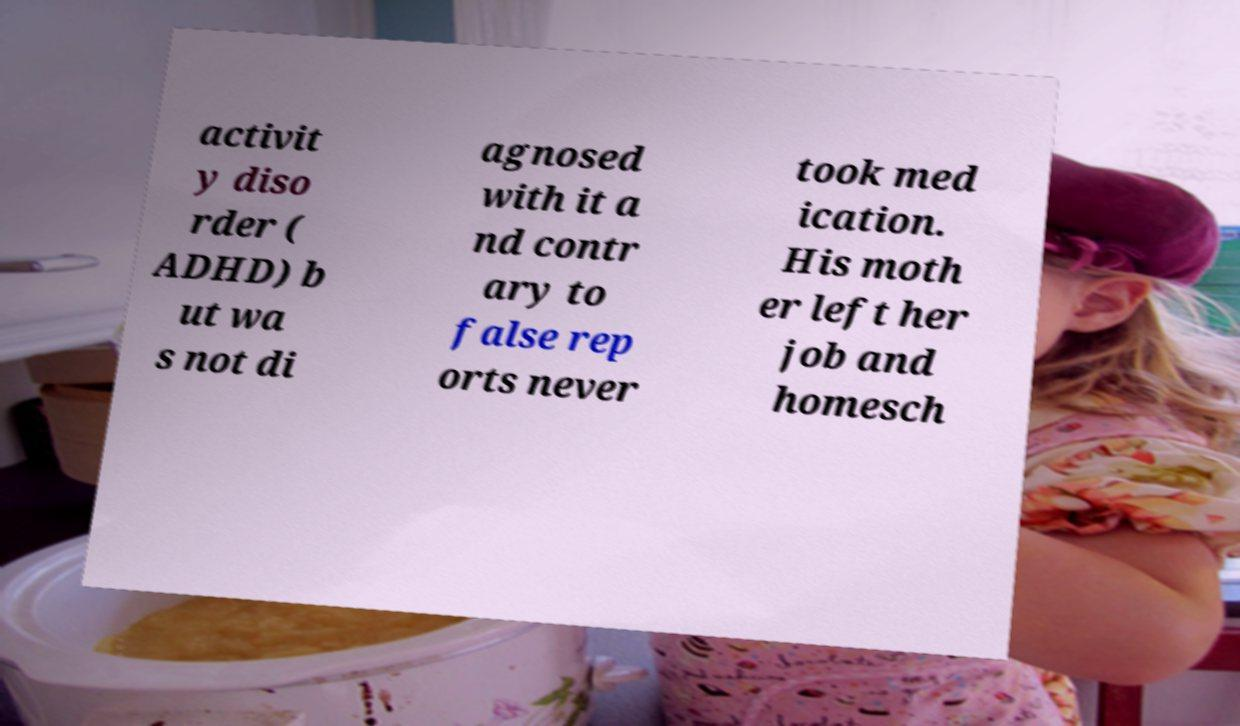Please identify and transcribe the text found in this image. activit y diso rder ( ADHD) b ut wa s not di agnosed with it a nd contr ary to false rep orts never took med ication. His moth er left her job and homesch 